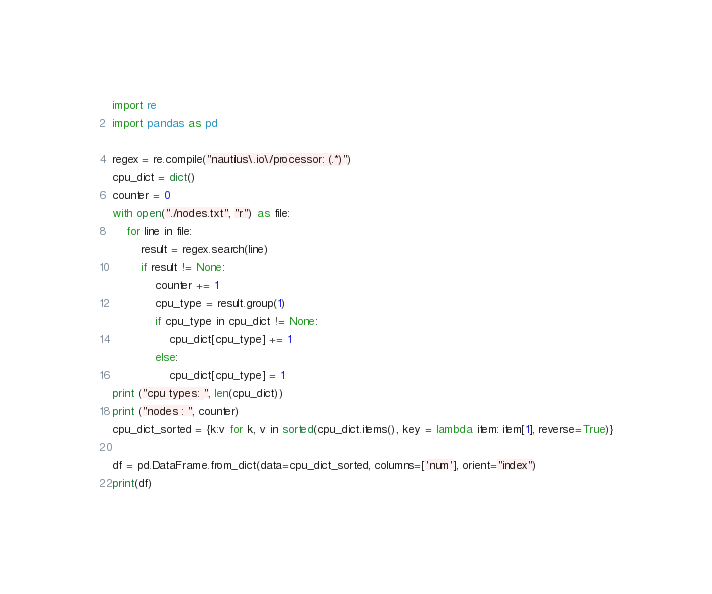<code> <loc_0><loc_0><loc_500><loc_500><_Python_>import re
import pandas as pd

regex = re.compile("nautilus\.io\/processor: (.*)")
cpu_dict = dict()
counter = 0
with open("./nodes.txt", "r") as file:
    for line in file:
        result = regex.search(line)
        if result != None:
            counter += 1
            cpu_type = result.group(1)
            if cpu_type in cpu_dict != None:
                cpu_dict[cpu_type] += 1
            else:
                cpu_dict[cpu_type] = 1
print ("cpu types: ", len(cpu_dict))
print ("nodes : ", counter)
cpu_dict_sorted = {k:v for k, v in sorted(cpu_dict.items(), key = lambda item: item[1], reverse=True)}

df = pd.DataFrame.from_dict(data=cpu_dict_sorted, columns=['num'], orient="index")
print(df)</code> 